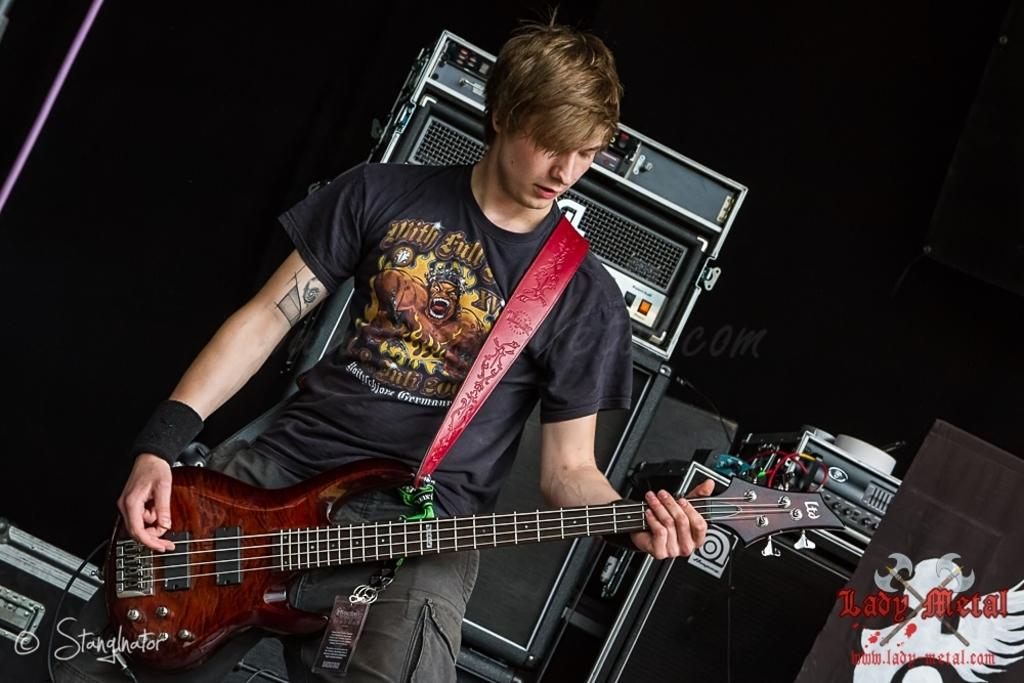What is the main subject of the image? The main subject of the image is a guy. What is the guy wearing? The guy is wearing a black shirt and black pants. What is the guy holding in the image? The guy is holding a guitar. What is the guy doing with the guitar? The guy is playing the guitar. What other musical equipment can be seen in the image? There are speakers and other musical instruments in the image. Can you see a crown on the guy's head in the image? No, there is no crown visible on the guy's head in the image. Are there any monkeys playing musical instruments in the image? No, there are no monkeys present in the image. 